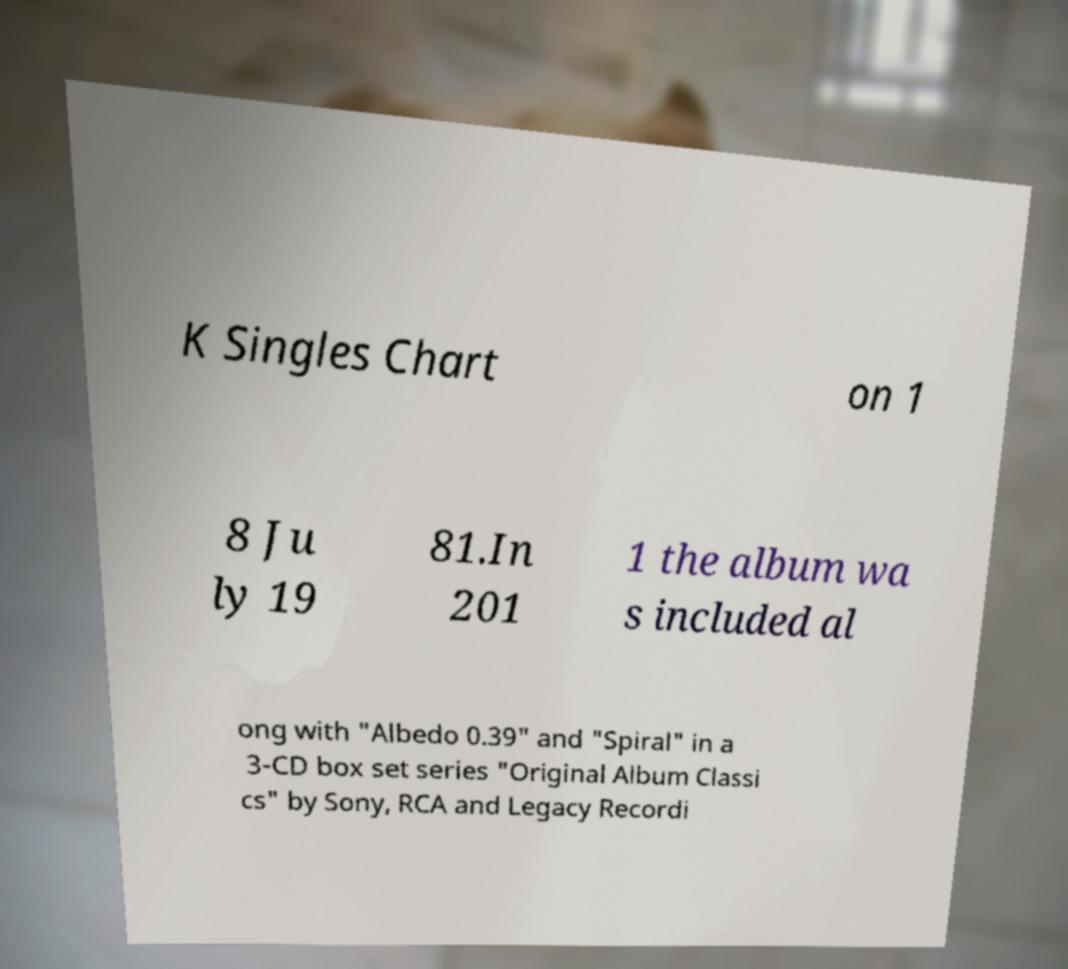For documentation purposes, I need the text within this image transcribed. Could you provide that? K Singles Chart on 1 8 Ju ly 19 81.In 201 1 the album wa s included al ong with "Albedo 0.39" and "Spiral" in a 3-CD box set series "Original Album Classi cs" by Sony, RCA and Legacy Recordi 